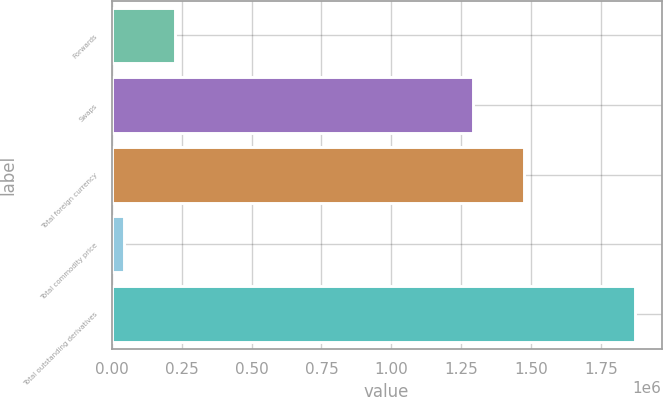Convert chart to OTSL. <chart><loc_0><loc_0><loc_500><loc_500><bar_chart><fcel>Forwards<fcel>Swaps<fcel>Total foreign currency<fcel>Total commodity price<fcel>Total outstanding derivatives<nl><fcel>228080<fcel>1.2916e+06<fcel>1.47424e+06<fcel>45439<fcel>1.87184e+06<nl></chart> 